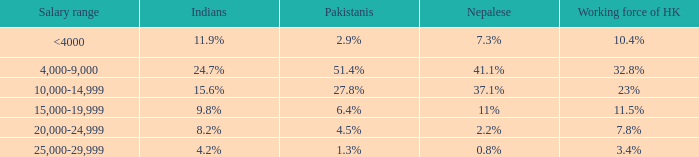If the salary range is 4,000-9,000, what is the Indians %? 24.7%. 